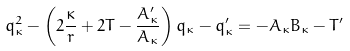<formula> <loc_0><loc_0><loc_500><loc_500>q _ { \kappa } ^ { 2 } - \left ( 2 \frac { \kappa } { r } + 2 T - \frac { A _ { \kappa } ^ { \prime } } { A _ { \kappa } } \right ) q _ { \kappa } - q _ { \kappa } ^ { \prime } = - A _ { \kappa } B _ { \kappa } - T ^ { \prime }</formula> 